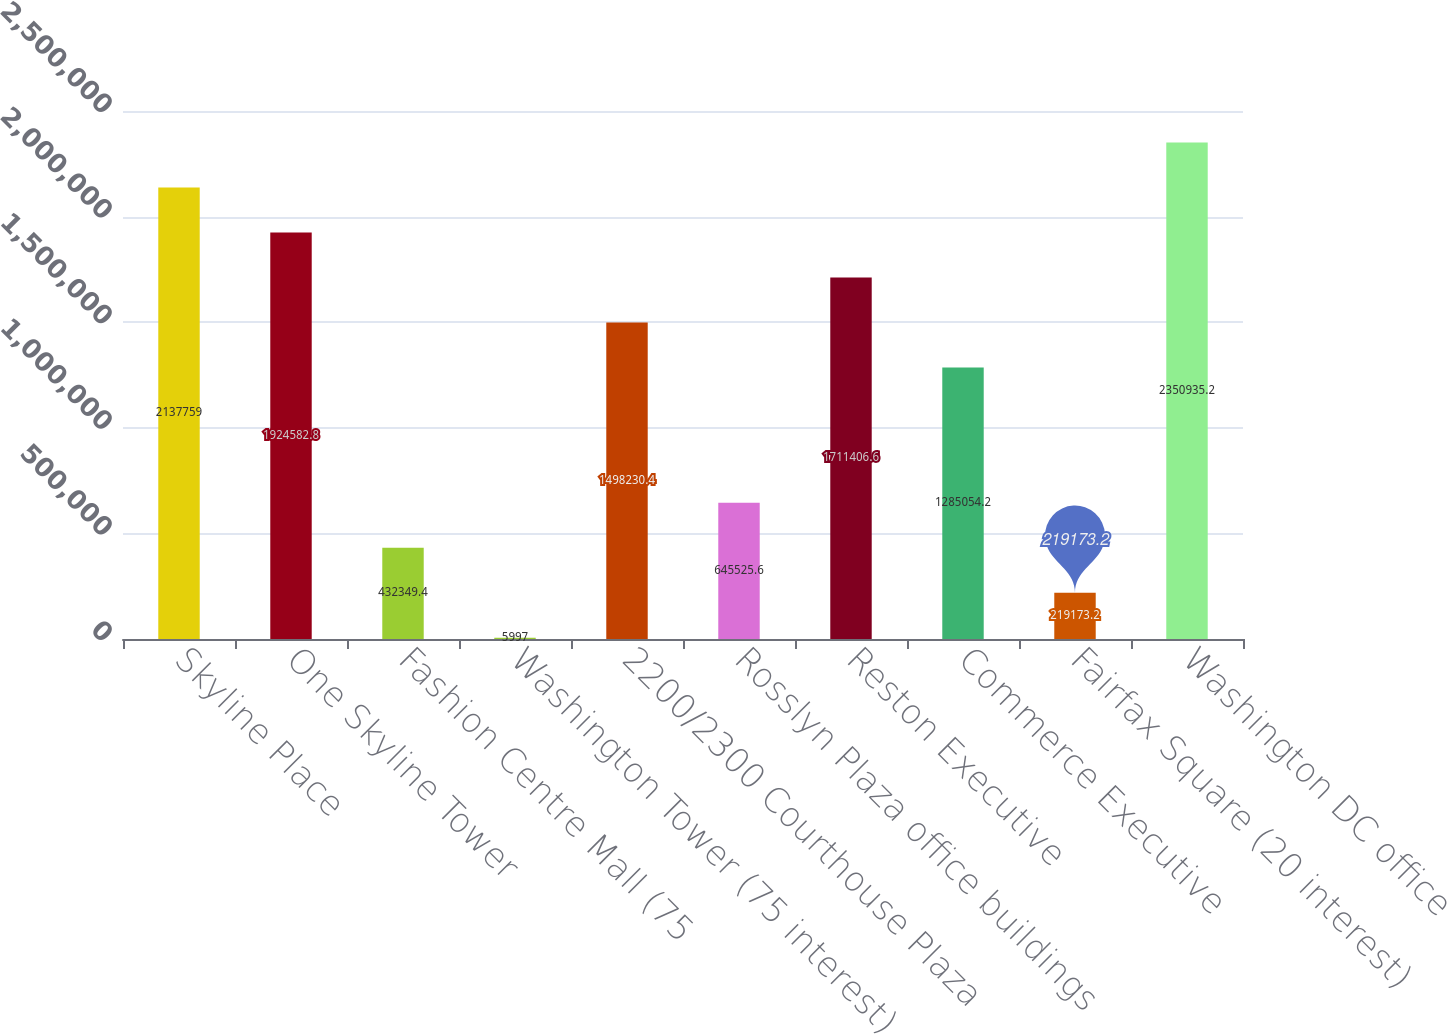Convert chart to OTSL. <chart><loc_0><loc_0><loc_500><loc_500><bar_chart><fcel>Skyline Place<fcel>One Skyline Tower<fcel>Fashion Centre Mall (75<fcel>Washington Tower (75 interest)<fcel>2200/2300 Courthouse Plaza<fcel>Rosslyn Plaza office buildings<fcel>Reston Executive<fcel>Commerce Executive<fcel>Fairfax Square (20 interest)<fcel>Washington DC office<nl><fcel>2.13776e+06<fcel>1.92458e+06<fcel>432349<fcel>5997<fcel>1.49823e+06<fcel>645526<fcel>1.71141e+06<fcel>1.28505e+06<fcel>219173<fcel>2.35094e+06<nl></chart> 